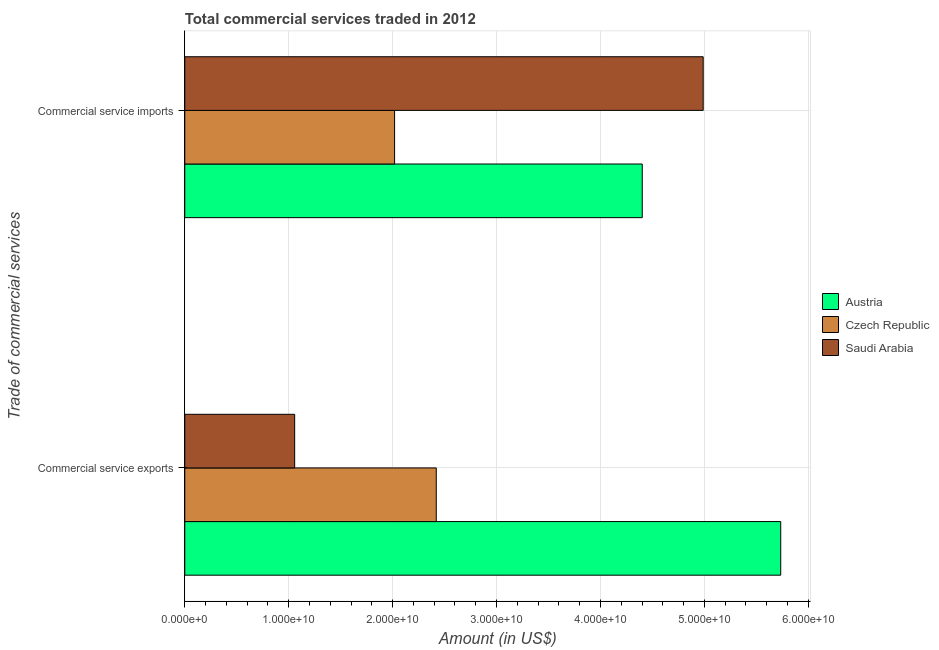How many different coloured bars are there?
Ensure brevity in your answer.  3. How many bars are there on the 1st tick from the top?
Offer a very short reply. 3. How many bars are there on the 1st tick from the bottom?
Offer a very short reply. 3. What is the label of the 2nd group of bars from the top?
Keep it short and to the point. Commercial service exports. What is the amount of commercial service exports in Austria?
Your answer should be compact. 5.73e+1. Across all countries, what is the maximum amount of commercial service imports?
Provide a short and direct response. 4.99e+1. Across all countries, what is the minimum amount of commercial service exports?
Make the answer very short. 1.06e+1. In which country was the amount of commercial service imports maximum?
Keep it short and to the point. Saudi Arabia. In which country was the amount of commercial service exports minimum?
Your answer should be very brief. Saudi Arabia. What is the total amount of commercial service imports in the graph?
Keep it short and to the point. 1.14e+11. What is the difference between the amount of commercial service imports in Austria and that in Saudi Arabia?
Your answer should be very brief. -5.86e+09. What is the difference between the amount of commercial service imports in Czech Republic and the amount of commercial service exports in Austria?
Provide a short and direct response. -3.72e+1. What is the average amount of commercial service exports per country?
Make the answer very short. 3.07e+1. What is the difference between the amount of commercial service imports and amount of commercial service exports in Austria?
Offer a very short reply. -1.33e+1. What is the ratio of the amount of commercial service imports in Saudi Arabia to that in Austria?
Offer a terse response. 1.13. Is the amount of commercial service exports in Austria less than that in Czech Republic?
Make the answer very short. No. What does the 3rd bar from the top in Commercial service imports represents?
Ensure brevity in your answer.  Austria. What does the 1st bar from the bottom in Commercial service exports represents?
Offer a very short reply. Austria. How many bars are there?
Make the answer very short. 6. How many countries are there in the graph?
Make the answer very short. 3. What is the difference between two consecutive major ticks on the X-axis?
Make the answer very short. 1.00e+1. Does the graph contain any zero values?
Ensure brevity in your answer.  No. Where does the legend appear in the graph?
Give a very brief answer. Center right. How many legend labels are there?
Your response must be concise. 3. How are the legend labels stacked?
Give a very brief answer. Vertical. What is the title of the graph?
Your answer should be very brief. Total commercial services traded in 2012. What is the label or title of the X-axis?
Make the answer very short. Amount (in US$). What is the label or title of the Y-axis?
Offer a terse response. Trade of commercial services. What is the Amount (in US$) of Austria in Commercial service exports?
Offer a terse response. 5.73e+1. What is the Amount (in US$) in Czech Republic in Commercial service exports?
Your answer should be compact. 2.42e+1. What is the Amount (in US$) of Saudi Arabia in Commercial service exports?
Offer a very short reply. 1.06e+1. What is the Amount (in US$) in Austria in Commercial service imports?
Offer a terse response. 4.40e+1. What is the Amount (in US$) of Czech Republic in Commercial service imports?
Offer a very short reply. 2.02e+1. What is the Amount (in US$) in Saudi Arabia in Commercial service imports?
Keep it short and to the point. 4.99e+1. Across all Trade of commercial services, what is the maximum Amount (in US$) in Austria?
Provide a short and direct response. 5.73e+1. Across all Trade of commercial services, what is the maximum Amount (in US$) in Czech Republic?
Make the answer very short. 2.42e+1. Across all Trade of commercial services, what is the maximum Amount (in US$) of Saudi Arabia?
Give a very brief answer. 4.99e+1. Across all Trade of commercial services, what is the minimum Amount (in US$) in Austria?
Give a very brief answer. 4.40e+1. Across all Trade of commercial services, what is the minimum Amount (in US$) of Czech Republic?
Provide a succinct answer. 2.02e+1. Across all Trade of commercial services, what is the minimum Amount (in US$) in Saudi Arabia?
Provide a succinct answer. 1.06e+1. What is the total Amount (in US$) of Austria in the graph?
Your answer should be compact. 1.01e+11. What is the total Amount (in US$) of Czech Republic in the graph?
Your answer should be very brief. 4.44e+1. What is the total Amount (in US$) of Saudi Arabia in the graph?
Your answer should be very brief. 6.05e+1. What is the difference between the Amount (in US$) of Austria in Commercial service exports and that in Commercial service imports?
Keep it short and to the point. 1.33e+1. What is the difference between the Amount (in US$) of Czech Republic in Commercial service exports and that in Commercial service imports?
Provide a short and direct response. 4.01e+09. What is the difference between the Amount (in US$) in Saudi Arabia in Commercial service exports and that in Commercial service imports?
Keep it short and to the point. -3.93e+1. What is the difference between the Amount (in US$) in Austria in Commercial service exports and the Amount (in US$) in Czech Republic in Commercial service imports?
Your answer should be compact. 3.72e+1. What is the difference between the Amount (in US$) in Austria in Commercial service exports and the Amount (in US$) in Saudi Arabia in Commercial service imports?
Offer a very short reply. 7.46e+09. What is the difference between the Amount (in US$) of Czech Republic in Commercial service exports and the Amount (in US$) of Saudi Arabia in Commercial service imports?
Ensure brevity in your answer.  -2.57e+1. What is the average Amount (in US$) in Austria per Trade of commercial services?
Make the answer very short. 5.07e+1. What is the average Amount (in US$) in Czech Republic per Trade of commercial services?
Your answer should be very brief. 2.22e+1. What is the average Amount (in US$) of Saudi Arabia per Trade of commercial services?
Make the answer very short. 3.02e+1. What is the difference between the Amount (in US$) in Austria and Amount (in US$) in Czech Republic in Commercial service exports?
Keep it short and to the point. 3.31e+1. What is the difference between the Amount (in US$) of Austria and Amount (in US$) of Saudi Arabia in Commercial service exports?
Keep it short and to the point. 4.68e+1. What is the difference between the Amount (in US$) in Czech Republic and Amount (in US$) in Saudi Arabia in Commercial service exports?
Give a very brief answer. 1.36e+1. What is the difference between the Amount (in US$) of Austria and Amount (in US$) of Czech Republic in Commercial service imports?
Offer a very short reply. 2.38e+1. What is the difference between the Amount (in US$) in Austria and Amount (in US$) in Saudi Arabia in Commercial service imports?
Your answer should be very brief. -5.86e+09. What is the difference between the Amount (in US$) of Czech Republic and Amount (in US$) of Saudi Arabia in Commercial service imports?
Provide a short and direct response. -2.97e+1. What is the ratio of the Amount (in US$) in Austria in Commercial service exports to that in Commercial service imports?
Your answer should be compact. 1.3. What is the ratio of the Amount (in US$) of Czech Republic in Commercial service exports to that in Commercial service imports?
Provide a succinct answer. 1.2. What is the ratio of the Amount (in US$) in Saudi Arabia in Commercial service exports to that in Commercial service imports?
Offer a terse response. 0.21. What is the difference between the highest and the second highest Amount (in US$) in Austria?
Offer a very short reply. 1.33e+1. What is the difference between the highest and the second highest Amount (in US$) of Czech Republic?
Your answer should be very brief. 4.01e+09. What is the difference between the highest and the second highest Amount (in US$) of Saudi Arabia?
Keep it short and to the point. 3.93e+1. What is the difference between the highest and the lowest Amount (in US$) in Austria?
Offer a very short reply. 1.33e+1. What is the difference between the highest and the lowest Amount (in US$) of Czech Republic?
Provide a succinct answer. 4.01e+09. What is the difference between the highest and the lowest Amount (in US$) of Saudi Arabia?
Your answer should be very brief. 3.93e+1. 